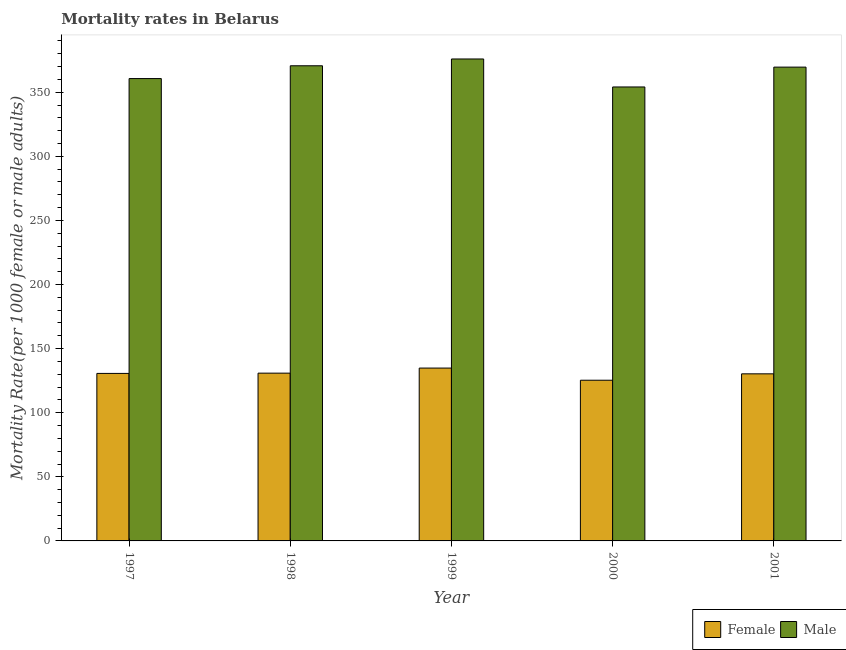Are the number of bars per tick equal to the number of legend labels?
Offer a very short reply. Yes. How many bars are there on the 3rd tick from the left?
Offer a very short reply. 2. What is the label of the 3rd group of bars from the left?
Ensure brevity in your answer.  1999. In how many cases, is the number of bars for a given year not equal to the number of legend labels?
Ensure brevity in your answer.  0. What is the male mortality rate in 1998?
Keep it short and to the point. 370.63. Across all years, what is the maximum male mortality rate?
Provide a short and direct response. 375.94. Across all years, what is the minimum female mortality rate?
Give a very brief answer. 125.35. In which year was the male mortality rate minimum?
Offer a very short reply. 2000. What is the total female mortality rate in the graph?
Ensure brevity in your answer.  652.05. What is the difference between the female mortality rate in 1998 and that in 1999?
Your answer should be compact. -3.96. What is the difference between the female mortality rate in 1997 and the male mortality rate in 1999?
Give a very brief answer. -4.17. What is the average female mortality rate per year?
Provide a short and direct response. 130.41. In how many years, is the female mortality rate greater than 90?
Your response must be concise. 5. What is the ratio of the female mortality rate in 1998 to that in 1999?
Offer a very short reply. 0.97. Is the male mortality rate in 1997 less than that in 1998?
Offer a terse response. Yes. What is the difference between the highest and the second highest female mortality rate?
Your answer should be very brief. 3.96. What is the difference between the highest and the lowest female mortality rate?
Your answer should be compact. 9.48. What does the 2nd bar from the right in 2001 represents?
Provide a short and direct response. Female. How many bars are there?
Your answer should be compact. 10. Does the graph contain any zero values?
Provide a succinct answer. No. Does the graph contain grids?
Your answer should be very brief. No. Where does the legend appear in the graph?
Offer a terse response. Bottom right. How many legend labels are there?
Give a very brief answer. 2. What is the title of the graph?
Your answer should be very brief. Mortality rates in Belarus. Does "Money lenders" appear as one of the legend labels in the graph?
Your answer should be very brief. No. What is the label or title of the Y-axis?
Offer a very short reply. Mortality Rate(per 1000 female or male adults). What is the Mortality Rate(per 1000 female or male adults) of Female in 1997?
Your response must be concise. 130.66. What is the Mortality Rate(per 1000 female or male adults) of Male in 1997?
Provide a succinct answer. 360.66. What is the Mortality Rate(per 1000 female or male adults) in Female in 1998?
Provide a short and direct response. 130.87. What is the Mortality Rate(per 1000 female or male adults) in Male in 1998?
Offer a very short reply. 370.63. What is the Mortality Rate(per 1000 female or male adults) in Female in 1999?
Keep it short and to the point. 134.83. What is the Mortality Rate(per 1000 female or male adults) of Male in 1999?
Your response must be concise. 375.94. What is the Mortality Rate(per 1000 female or male adults) in Female in 2000?
Give a very brief answer. 125.35. What is the Mortality Rate(per 1000 female or male adults) in Male in 2000?
Give a very brief answer. 354.11. What is the Mortality Rate(per 1000 female or male adults) of Female in 2001?
Provide a short and direct response. 130.34. What is the Mortality Rate(per 1000 female or male adults) of Male in 2001?
Your answer should be very brief. 369.59. Across all years, what is the maximum Mortality Rate(per 1000 female or male adults) in Female?
Ensure brevity in your answer.  134.83. Across all years, what is the maximum Mortality Rate(per 1000 female or male adults) of Male?
Ensure brevity in your answer.  375.94. Across all years, what is the minimum Mortality Rate(per 1000 female or male adults) of Female?
Keep it short and to the point. 125.35. Across all years, what is the minimum Mortality Rate(per 1000 female or male adults) in Male?
Offer a terse response. 354.11. What is the total Mortality Rate(per 1000 female or male adults) of Female in the graph?
Make the answer very short. 652.05. What is the total Mortality Rate(per 1000 female or male adults) in Male in the graph?
Offer a very short reply. 1830.94. What is the difference between the Mortality Rate(per 1000 female or male adults) of Female in 1997 and that in 1998?
Provide a short and direct response. -0.2. What is the difference between the Mortality Rate(per 1000 female or male adults) in Male in 1997 and that in 1998?
Your answer should be compact. -9.97. What is the difference between the Mortality Rate(per 1000 female or male adults) in Female in 1997 and that in 1999?
Provide a succinct answer. -4.17. What is the difference between the Mortality Rate(per 1000 female or male adults) in Male in 1997 and that in 1999?
Offer a terse response. -15.28. What is the difference between the Mortality Rate(per 1000 female or male adults) in Female in 1997 and that in 2000?
Ensure brevity in your answer.  5.31. What is the difference between the Mortality Rate(per 1000 female or male adults) of Male in 1997 and that in 2000?
Provide a succinct answer. 6.55. What is the difference between the Mortality Rate(per 1000 female or male adults) of Female in 1997 and that in 2001?
Provide a succinct answer. 0.32. What is the difference between the Mortality Rate(per 1000 female or male adults) of Male in 1997 and that in 2001?
Offer a terse response. -8.93. What is the difference between the Mortality Rate(per 1000 female or male adults) of Female in 1998 and that in 1999?
Keep it short and to the point. -3.96. What is the difference between the Mortality Rate(per 1000 female or male adults) in Male in 1998 and that in 1999?
Offer a terse response. -5.31. What is the difference between the Mortality Rate(per 1000 female or male adults) of Female in 1998 and that in 2000?
Offer a terse response. 5.51. What is the difference between the Mortality Rate(per 1000 female or male adults) of Male in 1998 and that in 2000?
Keep it short and to the point. 16.52. What is the difference between the Mortality Rate(per 1000 female or male adults) of Female in 1998 and that in 2001?
Your answer should be compact. 0.53. What is the difference between the Mortality Rate(per 1000 female or male adults) of Male in 1998 and that in 2001?
Your answer should be very brief. 1.05. What is the difference between the Mortality Rate(per 1000 female or male adults) of Female in 1999 and that in 2000?
Keep it short and to the point. 9.48. What is the difference between the Mortality Rate(per 1000 female or male adults) in Male in 1999 and that in 2000?
Your response must be concise. 21.83. What is the difference between the Mortality Rate(per 1000 female or male adults) in Female in 1999 and that in 2001?
Give a very brief answer. 4.49. What is the difference between the Mortality Rate(per 1000 female or male adults) of Male in 1999 and that in 2001?
Make the answer very short. 6.36. What is the difference between the Mortality Rate(per 1000 female or male adults) in Female in 2000 and that in 2001?
Offer a very short reply. -4.99. What is the difference between the Mortality Rate(per 1000 female or male adults) of Male in 2000 and that in 2001?
Offer a terse response. -15.48. What is the difference between the Mortality Rate(per 1000 female or male adults) in Female in 1997 and the Mortality Rate(per 1000 female or male adults) in Male in 1998?
Your response must be concise. -239.97. What is the difference between the Mortality Rate(per 1000 female or male adults) of Female in 1997 and the Mortality Rate(per 1000 female or male adults) of Male in 1999?
Make the answer very short. -245.28. What is the difference between the Mortality Rate(per 1000 female or male adults) of Female in 1997 and the Mortality Rate(per 1000 female or male adults) of Male in 2000?
Your response must be concise. -223.45. What is the difference between the Mortality Rate(per 1000 female or male adults) in Female in 1997 and the Mortality Rate(per 1000 female or male adults) in Male in 2001?
Provide a short and direct response. -238.93. What is the difference between the Mortality Rate(per 1000 female or male adults) of Female in 1998 and the Mortality Rate(per 1000 female or male adults) of Male in 1999?
Offer a very short reply. -245.08. What is the difference between the Mortality Rate(per 1000 female or male adults) in Female in 1998 and the Mortality Rate(per 1000 female or male adults) in Male in 2000?
Provide a succinct answer. -223.25. What is the difference between the Mortality Rate(per 1000 female or male adults) in Female in 1998 and the Mortality Rate(per 1000 female or male adults) in Male in 2001?
Make the answer very short. -238.72. What is the difference between the Mortality Rate(per 1000 female or male adults) in Female in 1999 and the Mortality Rate(per 1000 female or male adults) in Male in 2000?
Provide a short and direct response. -219.28. What is the difference between the Mortality Rate(per 1000 female or male adults) in Female in 1999 and the Mortality Rate(per 1000 female or male adults) in Male in 2001?
Provide a succinct answer. -234.76. What is the difference between the Mortality Rate(per 1000 female or male adults) of Female in 2000 and the Mortality Rate(per 1000 female or male adults) of Male in 2001?
Provide a succinct answer. -244.24. What is the average Mortality Rate(per 1000 female or male adults) in Female per year?
Offer a very short reply. 130.41. What is the average Mortality Rate(per 1000 female or male adults) in Male per year?
Provide a succinct answer. 366.19. In the year 1997, what is the difference between the Mortality Rate(per 1000 female or male adults) of Female and Mortality Rate(per 1000 female or male adults) of Male?
Your answer should be very brief. -230. In the year 1998, what is the difference between the Mortality Rate(per 1000 female or male adults) in Female and Mortality Rate(per 1000 female or male adults) in Male?
Ensure brevity in your answer.  -239.77. In the year 1999, what is the difference between the Mortality Rate(per 1000 female or male adults) of Female and Mortality Rate(per 1000 female or male adults) of Male?
Offer a terse response. -241.12. In the year 2000, what is the difference between the Mortality Rate(per 1000 female or male adults) of Female and Mortality Rate(per 1000 female or male adults) of Male?
Keep it short and to the point. -228.76. In the year 2001, what is the difference between the Mortality Rate(per 1000 female or male adults) of Female and Mortality Rate(per 1000 female or male adults) of Male?
Give a very brief answer. -239.25. What is the ratio of the Mortality Rate(per 1000 female or male adults) of Female in 1997 to that in 1998?
Your response must be concise. 1. What is the ratio of the Mortality Rate(per 1000 female or male adults) of Male in 1997 to that in 1998?
Offer a terse response. 0.97. What is the ratio of the Mortality Rate(per 1000 female or male adults) in Female in 1997 to that in 1999?
Your answer should be very brief. 0.97. What is the ratio of the Mortality Rate(per 1000 female or male adults) of Male in 1997 to that in 1999?
Ensure brevity in your answer.  0.96. What is the ratio of the Mortality Rate(per 1000 female or male adults) of Female in 1997 to that in 2000?
Your response must be concise. 1.04. What is the ratio of the Mortality Rate(per 1000 female or male adults) of Male in 1997 to that in 2000?
Provide a succinct answer. 1.02. What is the ratio of the Mortality Rate(per 1000 female or male adults) in Female in 1997 to that in 2001?
Provide a short and direct response. 1. What is the ratio of the Mortality Rate(per 1000 female or male adults) of Male in 1997 to that in 2001?
Make the answer very short. 0.98. What is the ratio of the Mortality Rate(per 1000 female or male adults) in Female in 1998 to that in 1999?
Your response must be concise. 0.97. What is the ratio of the Mortality Rate(per 1000 female or male adults) of Male in 1998 to that in 1999?
Offer a very short reply. 0.99. What is the ratio of the Mortality Rate(per 1000 female or male adults) in Female in 1998 to that in 2000?
Provide a short and direct response. 1.04. What is the ratio of the Mortality Rate(per 1000 female or male adults) of Male in 1998 to that in 2000?
Your response must be concise. 1.05. What is the ratio of the Mortality Rate(per 1000 female or male adults) in Female in 1999 to that in 2000?
Give a very brief answer. 1.08. What is the ratio of the Mortality Rate(per 1000 female or male adults) in Male in 1999 to that in 2000?
Offer a very short reply. 1.06. What is the ratio of the Mortality Rate(per 1000 female or male adults) of Female in 1999 to that in 2001?
Provide a short and direct response. 1.03. What is the ratio of the Mortality Rate(per 1000 female or male adults) in Male in 1999 to that in 2001?
Ensure brevity in your answer.  1.02. What is the ratio of the Mortality Rate(per 1000 female or male adults) in Female in 2000 to that in 2001?
Offer a very short reply. 0.96. What is the ratio of the Mortality Rate(per 1000 female or male adults) in Male in 2000 to that in 2001?
Your answer should be very brief. 0.96. What is the difference between the highest and the second highest Mortality Rate(per 1000 female or male adults) in Female?
Offer a terse response. 3.96. What is the difference between the highest and the second highest Mortality Rate(per 1000 female or male adults) in Male?
Your answer should be compact. 5.31. What is the difference between the highest and the lowest Mortality Rate(per 1000 female or male adults) of Female?
Your response must be concise. 9.48. What is the difference between the highest and the lowest Mortality Rate(per 1000 female or male adults) of Male?
Keep it short and to the point. 21.83. 